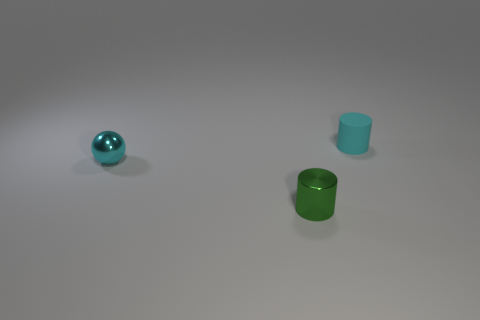How many matte objects are yellow things or tiny cyan spheres?
Make the answer very short. 0. There is a tiny object that is both right of the cyan shiny object and on the left side of the cyan matte thing; what is its material?
Offer a terse response. Metal. Is there a cyan thing to the left of the shiny object that is to the right of the cyan object to the left of the small cyan cylinder?
Offer a very short reply. Yes. Is there anything else that has the same material as the tiny cyan cylinder?
Provide a succinct answer. No. The thing that is made of the same material as the green cylinder is what shape?
Provide a succinct answer. Sphere. Is the number of tiny balls that are behind the metallic cylinder less than the number of metal things that are to the left of the cyan rubber thing?
Provide a succinct answer. Yes. How many tiny things are cyan things or matte objects?
Keep it short and to the point. 2. There is a small thing right of the small green thing; does it have the same shape as the object in front of the small metallic ball?
Offer a very short reply. Yes. There is a metal object that is in front of the cyan metal object; how big is it?
Give a very brief answer. Small. What is the tiny cylinder behind the metal cylinder made of?
Make the answer very short. Rubber. 